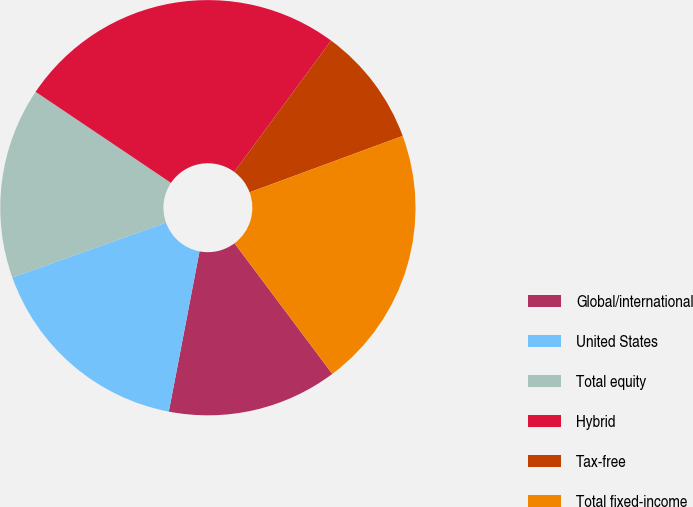Convert chart. <chart><loc_0><loc_0><loc_500><loc_500><pie_chart><fcel>Global/international<fcel>United States<fcel>Total equity<fcel>Hybrid<fcel>Tax-free<fcel>Total fixed-income<nl><fcel>13.24%<fcel>16.53%<fcel>14.88%<fcel>25.69%<fcel>9.27%<fcel>20.39%<nl></chart> 